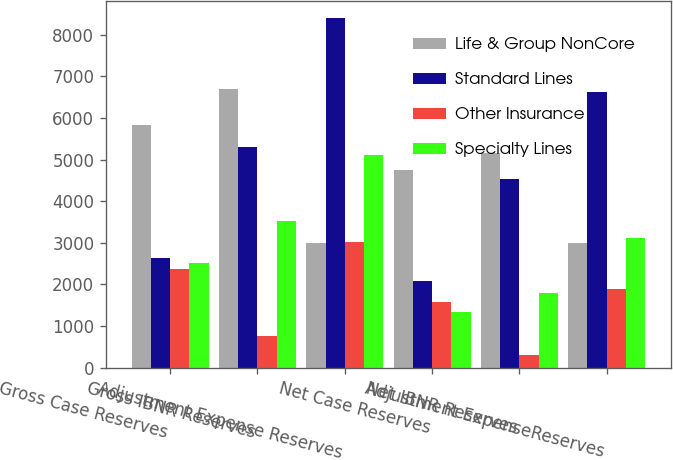Convert chart. <chart><loc_0><loc_0><loc_500><loc_500><stacked_bar_chart><ecel><fcel>Gross Case Reserves<fcel>Gross IBNR Reserves<fcel>Adjustment Expense Reserves<fcel>Net Case Reserves<fcel>Net IBNR Reserves<fcel>Adjustment ExpenseReserves<nl><fcel>Life & Group NonCore<fcel>5826<fcel>6691<fcel>2989<fcel>4750<fcel>5170<fcel>2989<nl><fcel>Standard Lines<fcel>2635<fcel>5311<fcel>8403<fcel>2090<fcel>4527<fcel>6617<nl><fcel>Other Insurance<fcel>2366<fcel>768<fcel>3027<fcel>1583<fcel>297<fcel>1880<nl><fcel>Specialty Lines<fcel>2511<fcel>3528<fcel>5110<fcel>1328<fcel>1787<fcel>3115<nl></chart> 